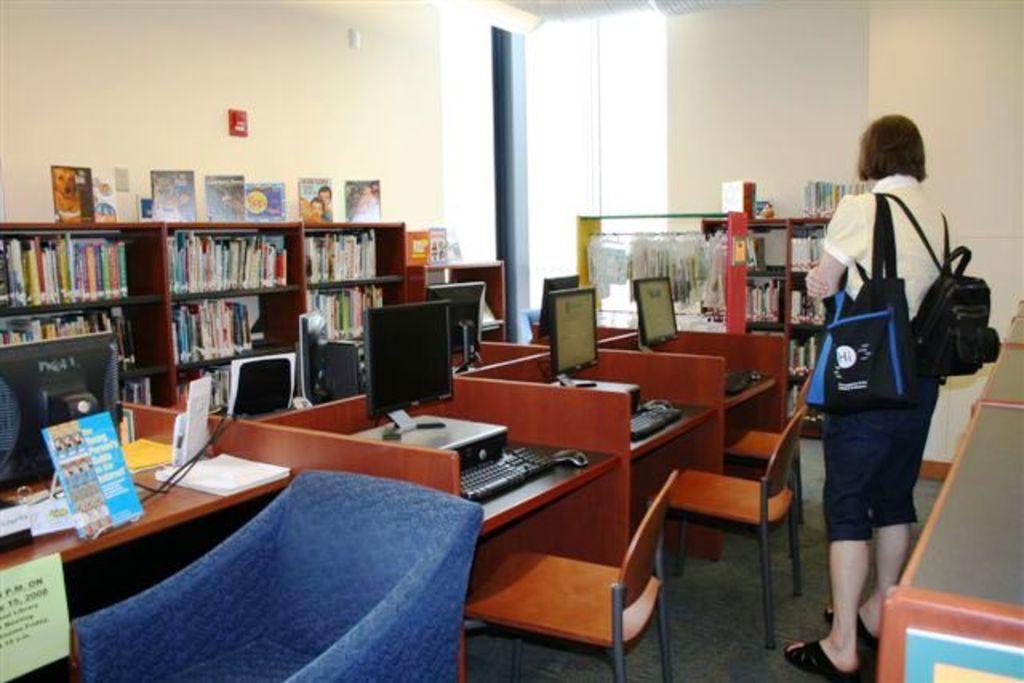Please provide a concise description of this image. A lady is standing wearing bags. In front of her there are tables, cupboards. On table there are computers, keyboard. And there are chairs. On the cupboard there are many book. In the background there is a wall with posters. On the side there are cupboards and some things are hanged in the cupboards. 